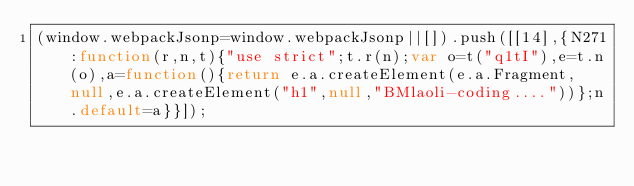<code> <loc_0><loc_0><loc_500><loc_500><_JavaScript_>(window.webpackJsonp=window.webpackJsonp||[]).push([[14],{N271:function(r,n,t){"use strict";t.r(n);var o=t("q1tI"),e=t.n(o),a=function(){return e.a.createElement(e.a.Fragment,null,e.a.createElement("h1",null,"BMlaoli-coding...."))};n.default=a}}]);
</code> 